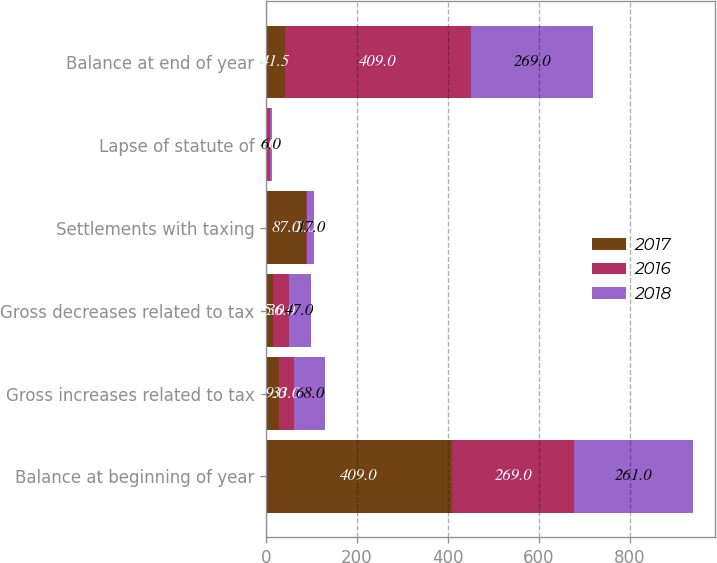Convert chart. <chart><loc_0><loc_0><loc_500><loc_500><stacked_bar_chart><ecel><fcel>Balance at beginning of year<fcel>Gross increases related to tax<fcel>Gross decreases related to tax<fcel>Settlements with taxing<fcel>Lapse of statute of<fcel>Balance at end of year<nl><fcel>2017<fcel>409<fcel>29<fcel>15<fcel>87<fcel>3<fcel>41.5<nl><fcel>2016<fcel>269<fcel>33<fcel>36<fcel>2<fcel>5<fcel>409<nl><fcel>2018<fcel>261<fcel>68<fcel>47<fcel>17<fcel>6<fcel>269<nl></chart> 